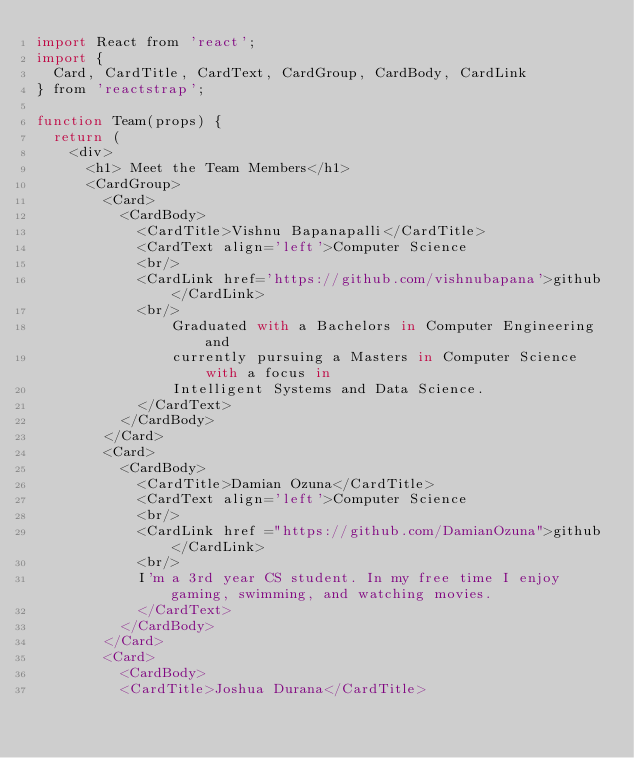<code> <loc_0><loc_0><loc_500><loc_500><_JavaScript_>import React from 'react';
import {
  Card, CardTitle, CardText, CardGroup, CardBody, CardLink
} from 'reactstrap';

function Team(props) {
  return (
    <div>
      <h1> Meet the Team Members</h1>
      <CardGroup>
        <Card>
          <CardBody>
            <CardTitle>Vishnu Bapanapalli</CardTitle>
            <CardText align='left'>Computer Science
            <br/>
            <CardLink href='https://github.com/vishnubapana'>github</CardLink>
            <br/>
                Graduated with a Bachelors in Computer Engineering and 
                currently pursuing a Masters in Computer Science with a focus in 
                Intelligent Systems and Data Science.
            </CardText>
          </CardBody>
        </Card>
        <Card>
          <CardBody>
            <CardTitle>Damian Ozuna</CardTitle>
            <CardText align='left'>Computer Science
            <br/>
            <CardLink href ="https://github.com/DamianOzuna">github</CardLink>
            <br/>
            I'm a 3rd year CS student. In my free time I enjoy gaming, swimming, and watching movies.
            </CardText>
          </CardBody>
        </Card>
        <Card>
          <CardBody>
          <CardTitle>Joshua Durana</CardTitle></code> 